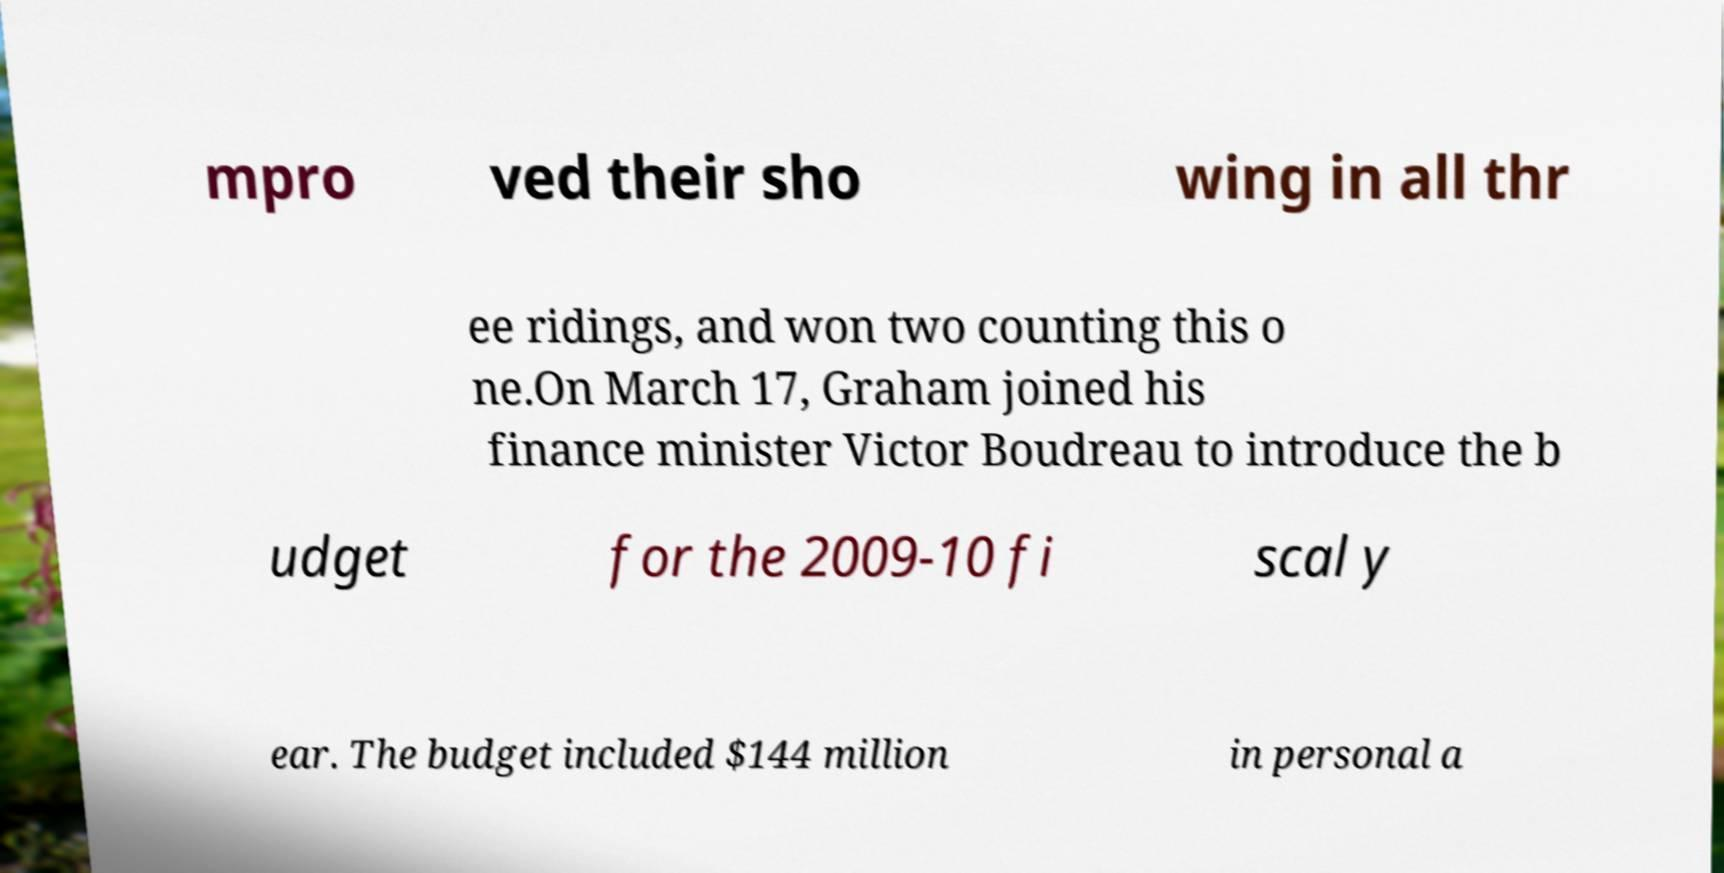What messages or text are displayed in this image? I need them in a readable, typed format. mpro ved their sho wing in all thr ee ridings, and won two counting this o ne.On March 17, Graham joined his finance minister Victor Boudreau to introduce the b udget for the 2009-10 fi scal y ear. The budget included $144 million in personal a 